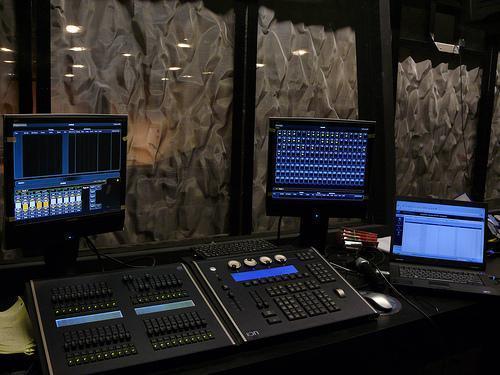How many monitors are on?
Give a very brief answer. 3. 